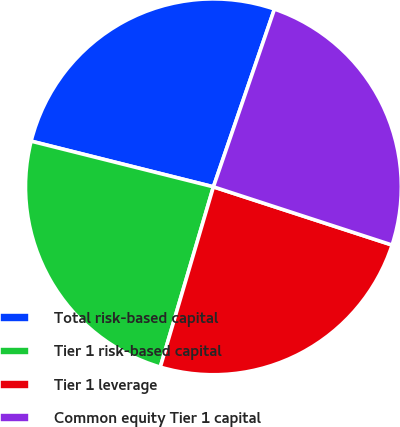Convert chart to OTSL. <chart><loc_0><loc_0><loc_500><loc_500><pie_chart><fcel>Total risk-based capital<fcel>Tier 1 risk-based capital<fcel>Tier 1 leverage<fcel>Common equity Tier 1 capital<nl><fcel>26.36%<fcel>24.35%<fcel>24.55%<fcel>24.75%<nl></chart> 